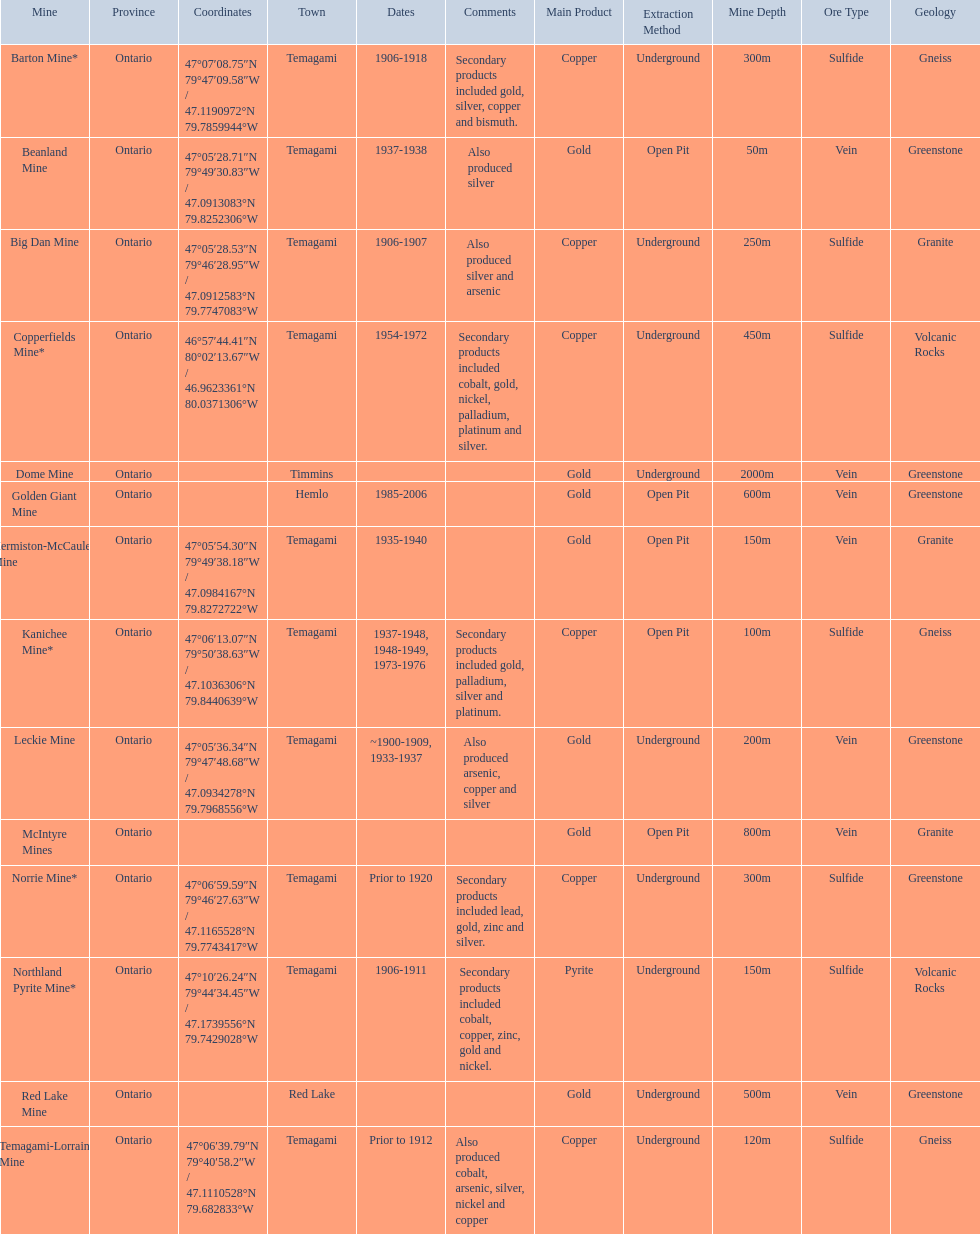What years was the golden giant mine open for? 1985-2006. What years was the beanland mine open? 1937-1938. Which of these two mines was open longer? Golden Giant Mine. 